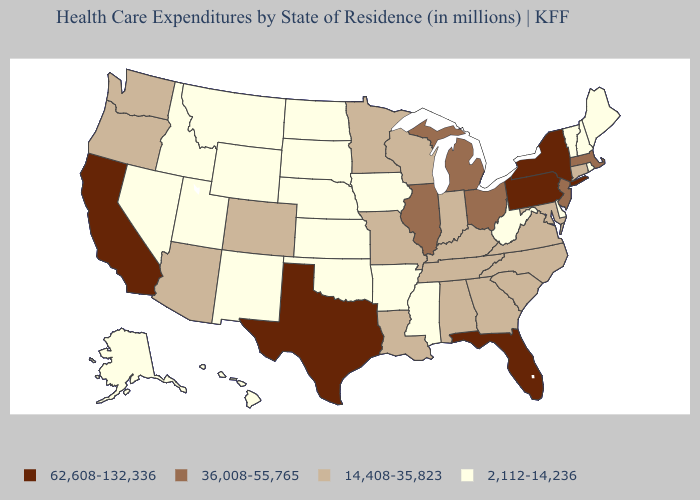What is the highest value in states that border Texas?
Give a very brief answer. 14,408-35,823. Name the states that have a value in the range 62,608-132,336?
Be succinct. California, Florida, New York, Pennsylvania, Texas. Does Florida have the highest value in the USA?
Answer briefly. Yes. What is the value of New Jersey?
Keep it brief. 36,008-55,765. Does Delaware have a higher value than Connecticut?
Answer briefly. No. What is the value of California?
Write a very short answer. 62,608-132,336. What is the value of Nebraska?
Concise answer only. 2,112-14,236. What is the value of Alabama?
Be succinct. 14,408-35,823. Does Wisconsin have the same value as Michigan?
Concise answer only. No. Name the states that have a value in the range 14,408-35,823?
Write a very short answer. Alabama, Arizona, Colorado, Connecticut, Georgia, Indiana, Kentucky, Louisiana, Maryland, Minnesota, Missouri, North Carolina, Oregon, South Carolina, Tennessee, Virginia, Washington, Wisconsin. What is the lowest value in the West?
Concise answer only. 2,112-14,236. Among the states that border Arizona , which have the highest value?
Short answer required. California. Name the states that have a value in the range 2,112-14,236?
Concise answer only. Alaska, Arkansas, Delaware, Hawaii, Idaho, Iowa, Kansas, Maine, Mississippi, Montana, Nebraska, Nevada, New Hampshire, New Mexico, North Dakota, Oklahoma, Rhode Island, South Dakota, Utah, Vermont, West Virginia, Wyoming. Among the states that border South Carolina , which have the highest value?
Short answer required. Georgia, North Carolina. 